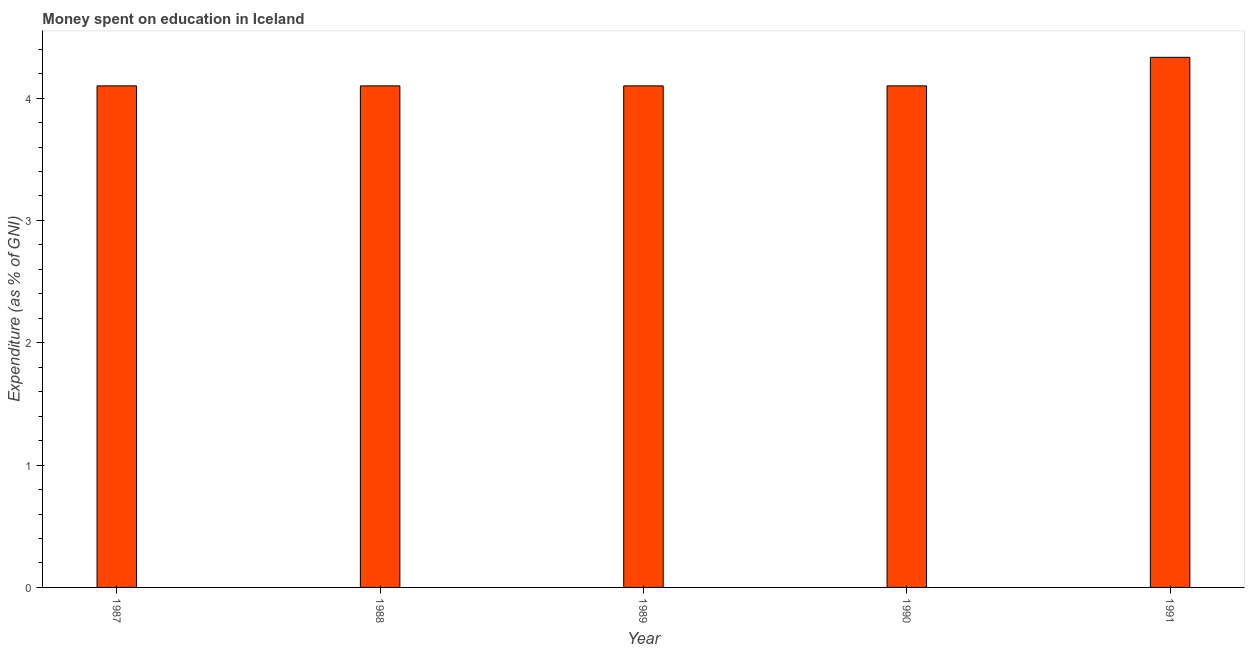Does the graph contain any zero values?
Provide a succinct answer. No. Does the graph contain grids?
Provide a succinct answer. No. What is the title of the graph?
Your answer should be very brief. Money spent on education in Iceland. What is the label or title of the X-axis?
Provide a succinct answer. Year. What is the label or title of the Y-axis?
Your answer should be compact. Expenditure (as % of GNI). What is the expenditure on education in 1990?
Provide a short and direct response. 4.1. Across all years, what is the maximum expenditure on education?
Make the answer very short. 4.33. What is the sum of the expenditure on education?
Make the answer very short. 20.73. What is the difference between the expenditure on education in 1987 and 1989?
Your answer should be very brief. 0. What is the average expenditure on education per year?
Offer a terse response. 4.15. What is the ratio of the expenditure on education in 1989 to that in 1991?
Give a very brief answer. 0.95. Is the expenditure on education in 1987 less than that in 1989?
Your answer should be compact. No. What is the difference between the highest and the second highest expenditure on education?
Your answer should be compact. 0.23. What is the difference between the highest and the lowest expenditure on education?
Make the answer very short. 0.23. In how many years, is the expenditure on education greater than the average expenditure on education taken over all years?
Your response must be concise. 1. Are the values on the major ticks of Y-axis written in scientific E-notation?
Your answer should be compact. No. What is the Expenditure (as % of GNI) in 1991?
Offer a terse response. 4.33. What is the difference between the Expenditure (as % of GNI) in 1987 and 1988?
Offer a very short reply. 0. What is the difference between the Expenditure (as % of GNI) in 1987 and 1991?
Make the answer very short. -0.23. What is the difference between the Expenditure (as % of GNI) in 1988 and 1989?
Your response must be concise. 0. What is the difference between the Expenditure (as % of GNI) in 1988 and 1990?
Provide a succinct answer. 0. What is the difference between the Expenditure (as % of GNI) in 1988 and 1991?
Ensure brevity in your answer.  -0.23. What is the difference between the Expenditure (as % of GNI) in 1989 and 1991?
Your response must be concise. -0.23. What is the difference between the Expenditure (as % of GNI) in 1990 and 1991?
Keep it short and to the point. -0.23. What is the ratio of the Expenditure (as % of GNI) in 1987 to that in 1988?
Keep it short and to the point. 1. What is the ratio of the Expenditure (as % of GNI) in 1987 to that in 1990?
Your response must be concise. 1. What is the ratio of the Expenditure (as % of GNI) in 1987 to that in 1991?
Make the answer very short. 0.95. What is the ratio of the Expenditure (as % of GNI) in 1988 to that in 1989?
Your answer should be compact. 1. What is the ratio of the Expenditure (as % of GNI) in 1988 to that in 1990?
Provide a short and direct response. 1. What is the ratio of the Expenditure (as % of GNI) in 1988 to that in 1991?
Provide a succinct answer. 0.95. What is the ratio of the Expenditure (as % of GNI) in 1989 to that in 1991?
Your response must be concise. 0.95. What is the ratio of the Expenditure (as % of GNI) in 1990 to that in 1991?
Give a very brief answer. 0.95. 